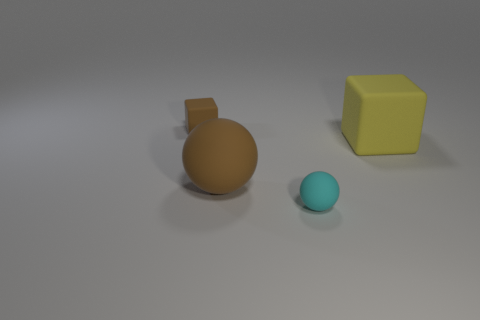Add 4 large brown rubber cylinders. How many objects exist? 8 Add 4 large cyan matte blocks. How many large cyan matte blocks exist? 4 Subtract 0 purple blocks. How many objects are left? 4 Subtract all matte balls. Subtract all cyan balls. How many objects are left? 1 Add 3 big rubber objects. How many big rubber objects are left? 5 